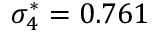<formula> <loc_0><loc_0><loc_500><loc_500>\sigma _ { 4 } ^ { * } = 0 . 7 6 1</formula> 